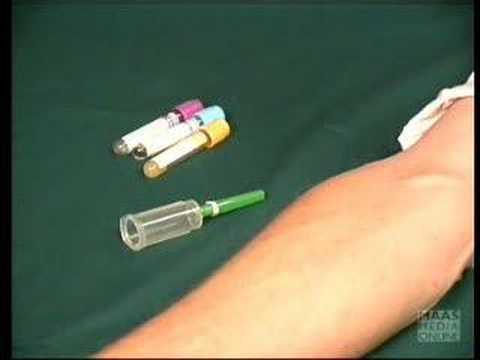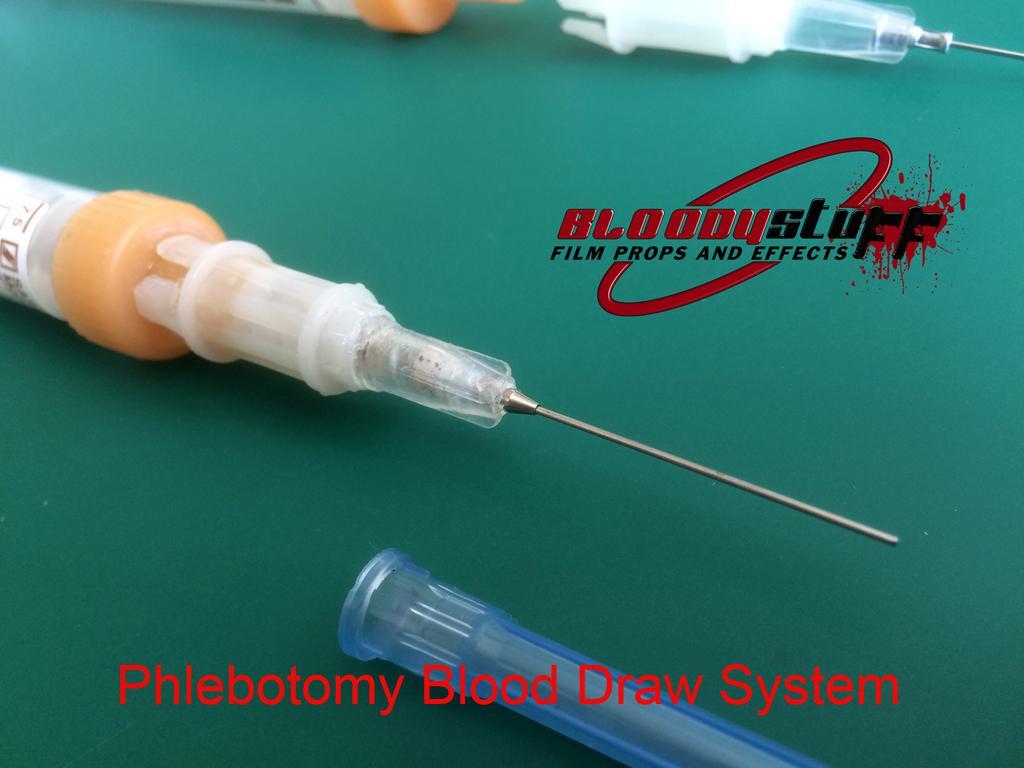The first image is the image on the left, the second image is the image on the right. Analyze the images presented: Is the assertion "A human arm is shown next to a medical instrument" valid? Answer yes or no. Yes. The first image is the image on the left, the second image is the image on the right. Given the left and right images, does the statement "there is an arm in the image on the left" hold true? Answer yes or no. Yes. 